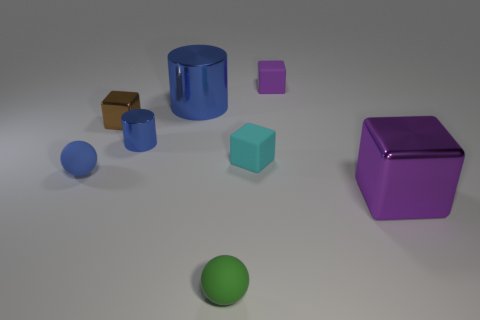Are there any large purple cubes in front of the small purple thing?
Provide a short and direct response. Yes. There is a tiny block in front of the brown thing; is there a large purple thing left of it?
Make the answer very short. No. Are there fewer tiny blue objects left of the tiny brown object than purple blocks that are on the right side of the tiny green matte sphere?
Ensure brevity in your answer.  Yes. There is a green thing; what shape is it?
Make the answer very short. Sphere. What is the material of the small ball that is behind the green rubber sphere?
Your answer should be compact. Rubber. There is a matte sphere right of the sphere that is behind the large metal object right of the tiny purple rubber block; what size is it?
Your answer should be very brief. Small. Is the purple cube that is behind the blue matte sphere made of the same material as the purple block in front of the tiny cyan rubber object?
Offer a terse response. No. How many other things are there of the same color as the small shiny cylinder?
Offer a very short reply. 2. How many objects are either tiny rubber cubes to the left of the tiny purple thing or objects in front of the small blue sphere?
Your answer should be very brief. 3. What size is the metal block behind the matte sphere that is to the left of the small blue cylinder?
Your response must be concise. Small. 